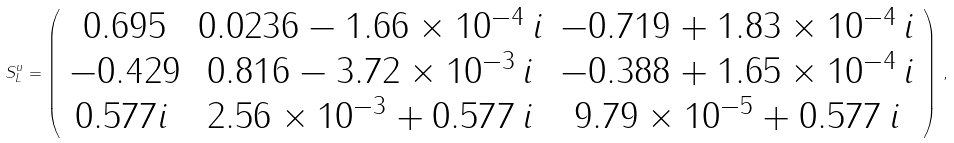<formula> <loc_0><loc_0><loc_500><loc_500>S _ { L } ^ { u } = \left ( \begin{array} { c c c } 0 . 6 9 5 & 0 . 0 2 3 6 - 1 . 6 6 \times 1 0 ^ { - 4 } \, i & - 0 . 7 1 9 + 1 . 8 3 \times 1 0 ^ { - 4 } \, i \\ - 0 . 4 2 9 & 0 . 8 1 6 - 3 . 7 2 \times 1 0 ^ { - 3 } \, i & - 0 . 3 8 8 + 1 . 6 5 \times 1 0 ^ { - 4 } \, i \\ 0 . 5 7 7 i \, & 2 . 5 6 \times 1 0 ^ { - 3 } + 0 . 5 7 7 \, i & 9 . 7 9 \times 1 0 ^ { - 5 } + 0 . 5 7 7 \, i \end{array} \right ) \, ,</formula> 